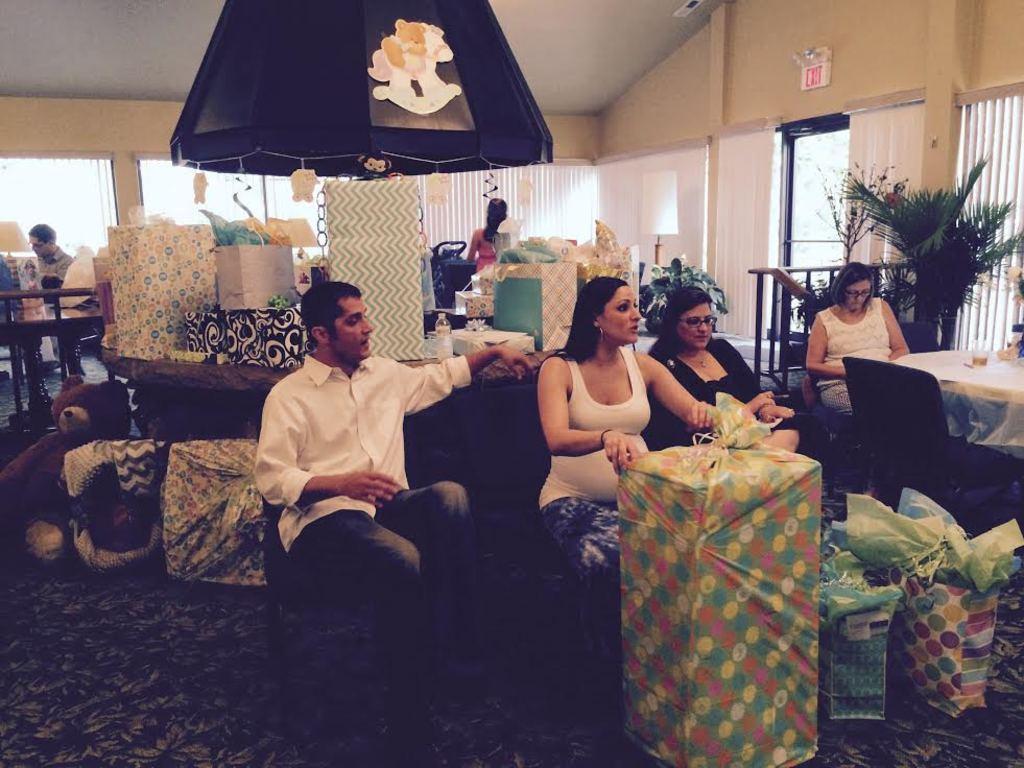In one or two sentences, can you explain what this image depicts? In this picture we can see some persons are sitting on the chairs. This is the floor and there is a table. And in the background we can see some boxes on the table. And this is a plant. And this is the door. 